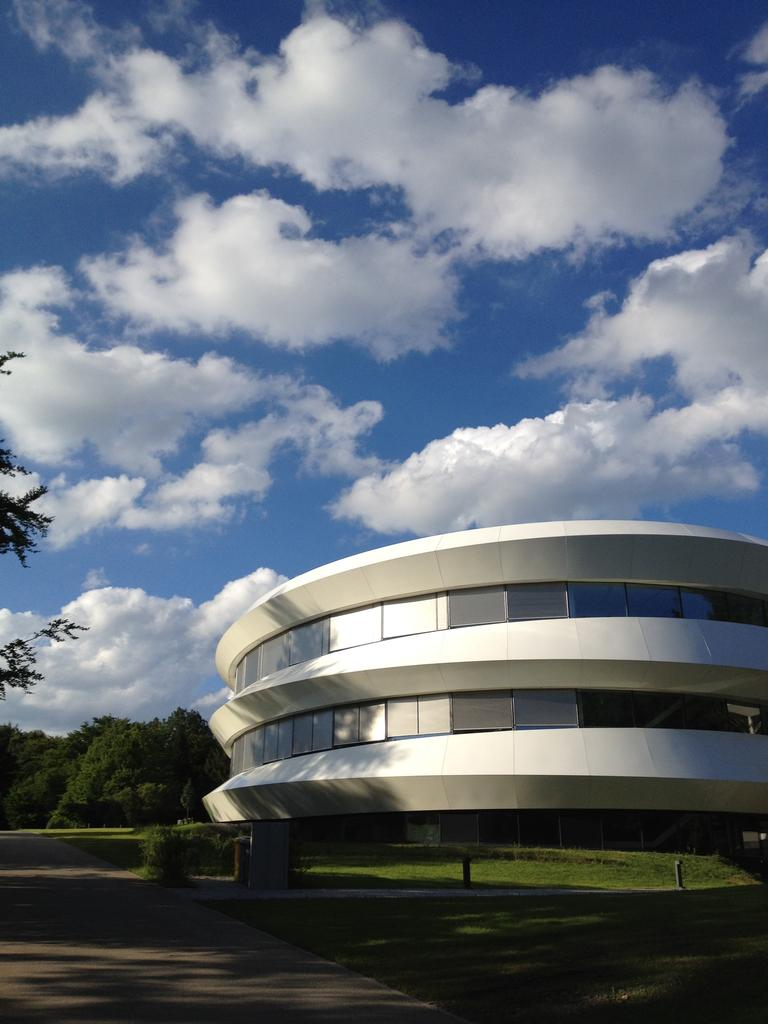What is located in the foreground of the image? There is a building and grassland in the foreground of the image. What type of vegetation can be seen in the foreground? There is grassland in the foreground of the image. What is visible in the background of the image? There are trees and the sky in the background of the image. How many oranges are hanging from the trees in the image? There are no oranges visible in the image, as it features trees in the background. What type of chain can be seen connecting the building to the sky in the image? There is no chain connecting the building to the sky in the image. 